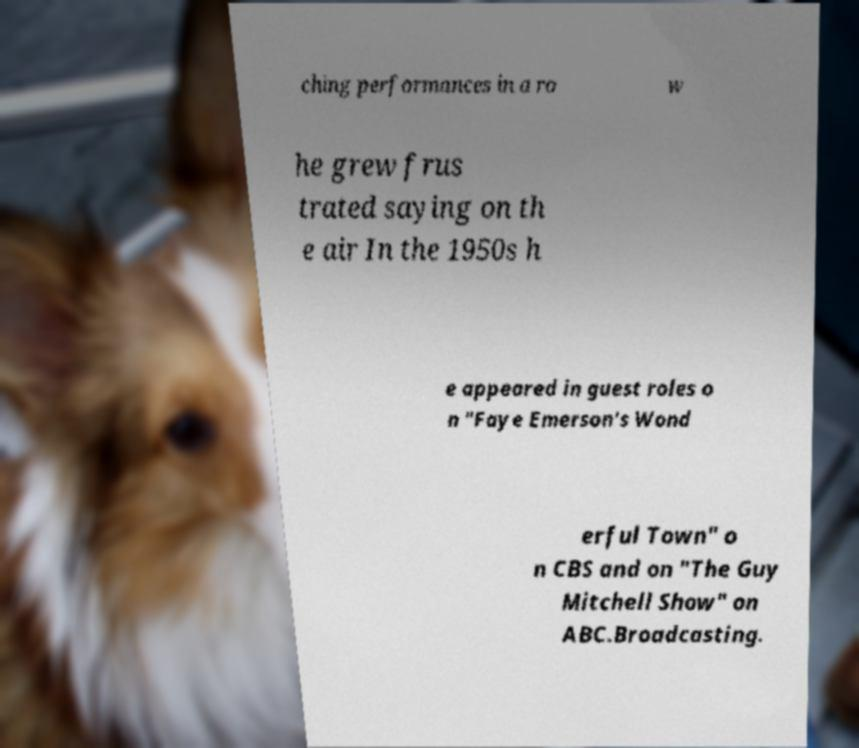What messages or text are displayed in this image? I need them in a readable, typed format. ching performances in a ro w he grew frus trated saying on th e air In the 1950s h e appeared in guest roles o n "Faye Emerson's Wond erful Town" o n CBS and on "The Guy Mitchell Show" on ABC.Broadcasting. 